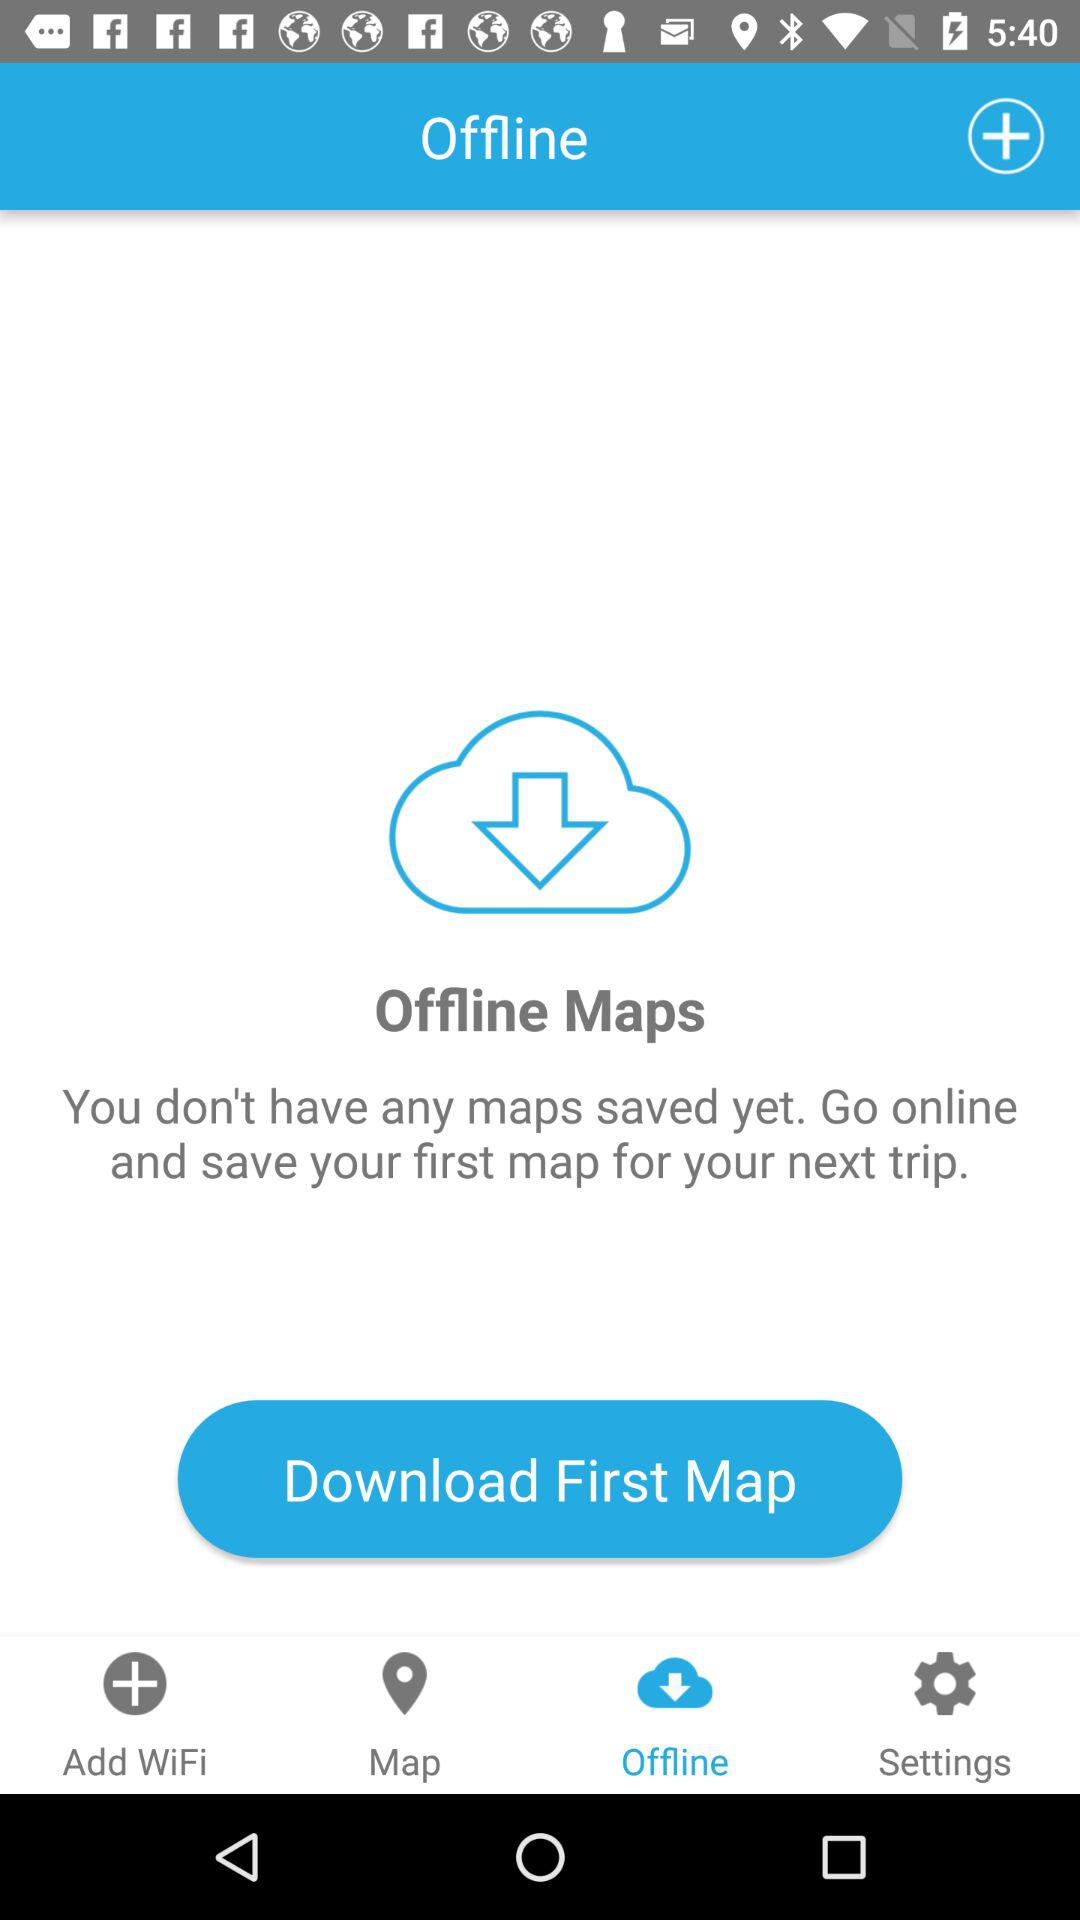Which WiFi connections are available?
When the provided information is insufficient, respond with <no answer>. <no answer> 